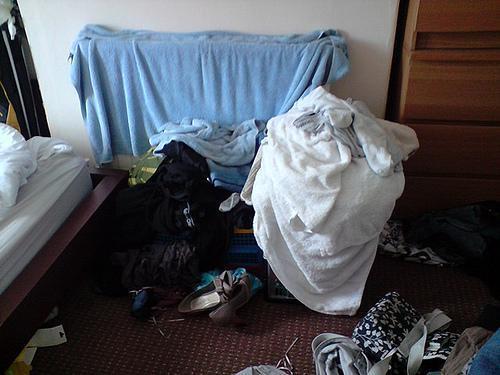How many shoes are there?
Give a very brief answer. 1. How many men are wearing black hats?
Give a very brief answer. 0. 